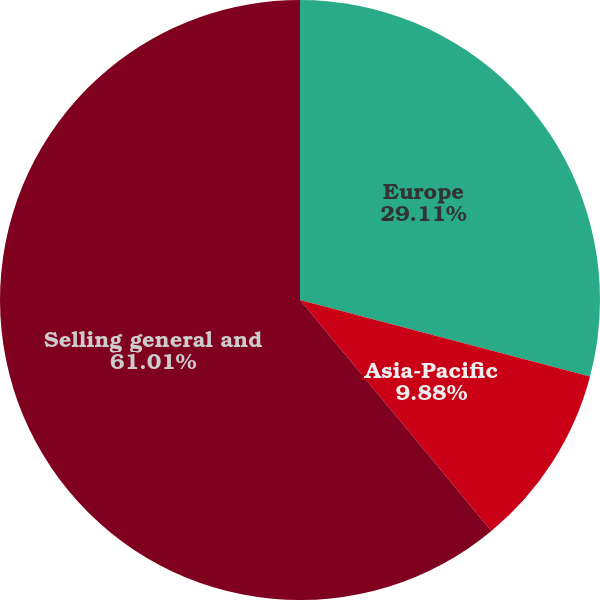Convert chart. <chart><loc_0><loc_0><loc_500><loc_500><pie_chart><fcel>Europe<fcel>Asia-Pacific<fcel>Selling general and<nl><fcel>29.11%<fcel>9.88%<fcel>61.01%<nl></chart> 